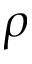Convert formula to latex. <formula><loc_0><loc_0><loc_500><loc_500>\rho</formula> 